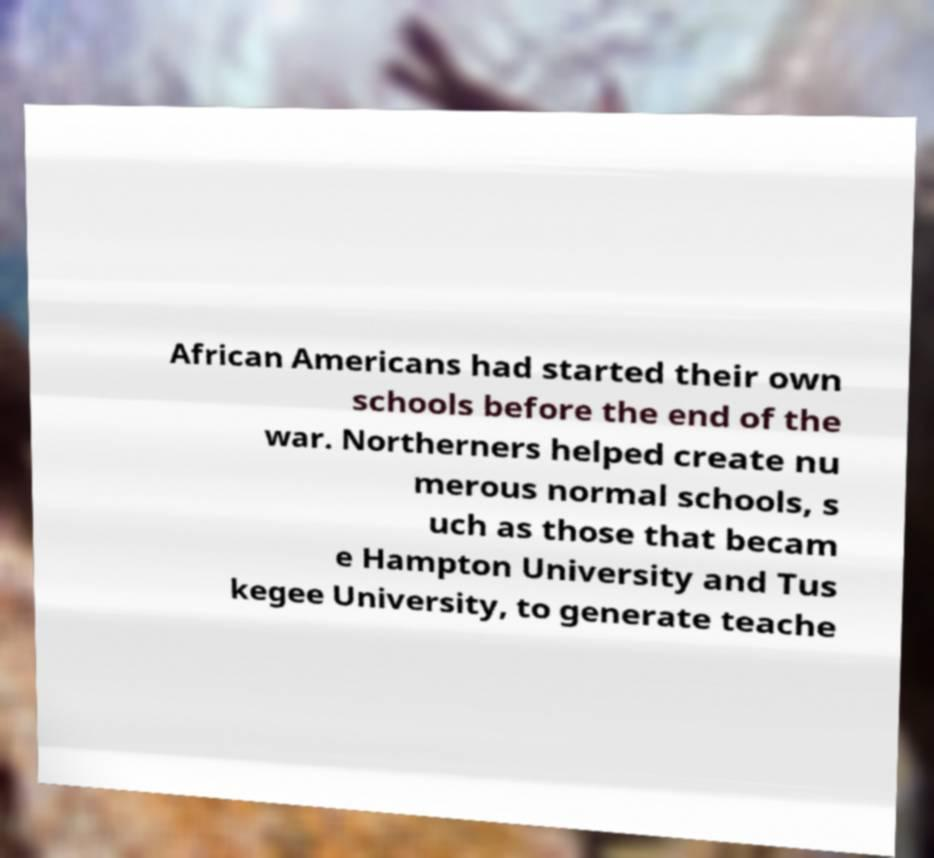Can you read and provide the text displayed in the image?This photo seems to have some interesting text. Can you extract and type it out for me? African Americans had started their own schools before the end of the war. Northerners helped create nu merous normal schools, s uch as those that becam e Hampton University and Tus kegee University, to generate teache 